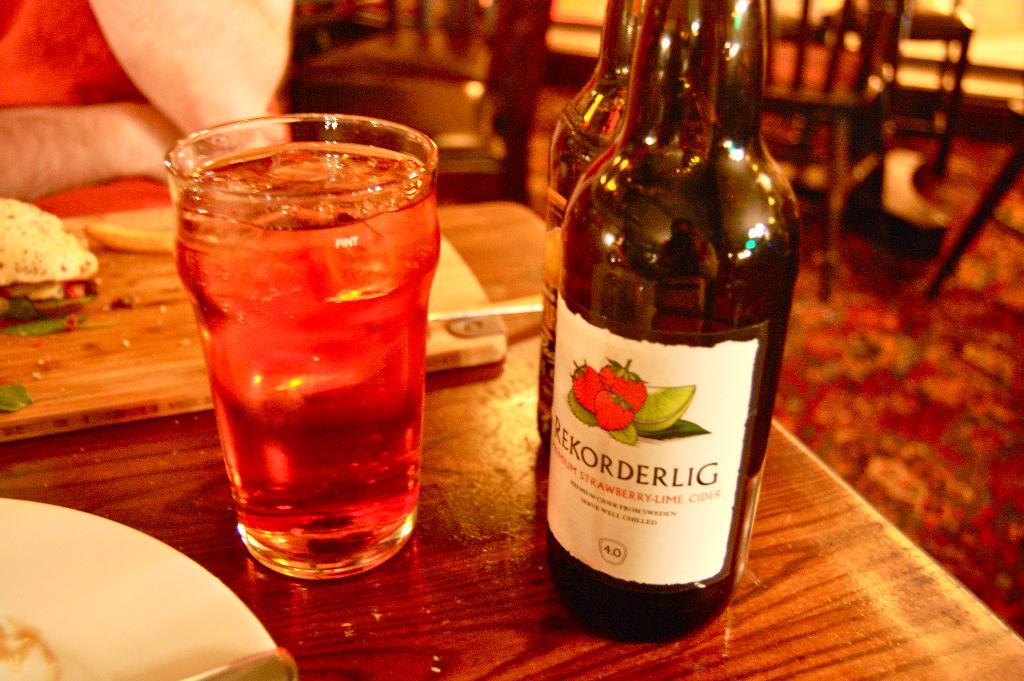What kind of beverage is in the bottle?
Make the answer very short. Cider. What is the number on the bottle?
Keep it short and to the point. 40. 